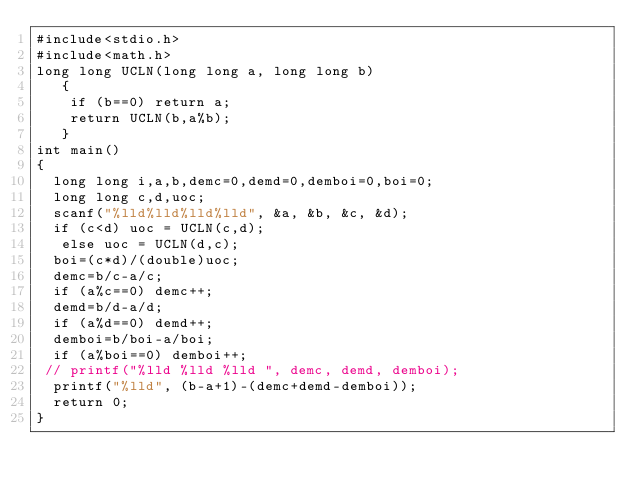Convert code to text. <code><loc_0><loc_0><loc_500><loc_500><_C_>#include<stdio.h>
#include<math.h>
long long UCLN(long long a, long long b)
   {
   	if (b==0) return a;
   	return UCLN(b,a%b);
   }
int main()
{
  long long i,a,b,demc=0,demd=0,demboi=0,boi=0;
  long long c,d,uoc;
  scanf("%lld%lld%lld%lld", &a, &b, &c, &d);
  if (c<d) uoc = UCLN(c,d);
   else uoc = UCLN(d,c);
  boi=(c*d)/(double)uoc;
  demc=b/c-a/c;
  if (a%c==0) demc++;
  demd=b/d-a/d;
  if (a%d==0) demd++;
  demboi=b/boi-a/boi;
  if (a%boi==0) demboi++;
 // printf("%lld %lld %lld ", demc, demd, demboi);
  printf("%lld", (b-a+1)-(demc+demd-demboi));
  return 0;
}
</code> 